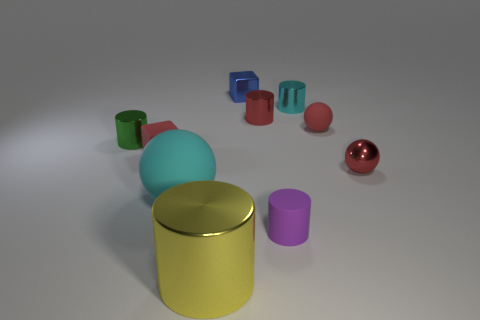Can you describe the arrangement of the objects in the image? Certainly! The image displays a collection of cylinders and spheres with various colors, sizes, and materials. The objects are arranged on a flat surface, with a prominent yellow cylinder at the forefront, a medium-sized cyan sphere slightly behind it, and other cylinders and a sphere scattered in the background with varying perspectives indicating depth. 